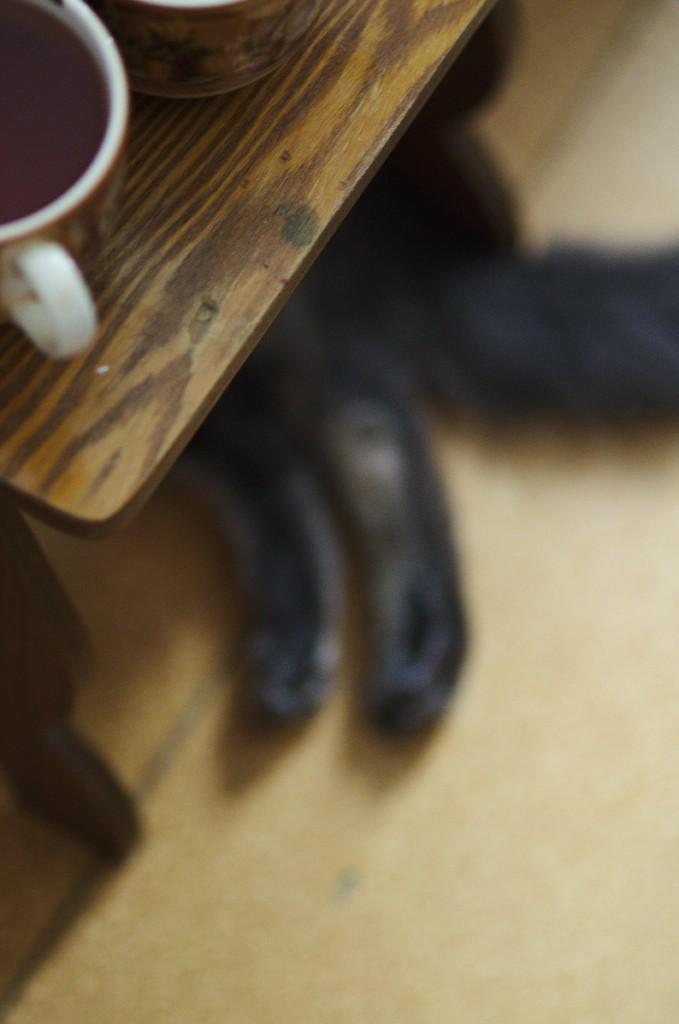Could you give a brief overview of what you see in this image? On the left a table is visible on which cup is kept. Below that cat is there which is half visible and lying on the floor. This image is taken inside the house. 